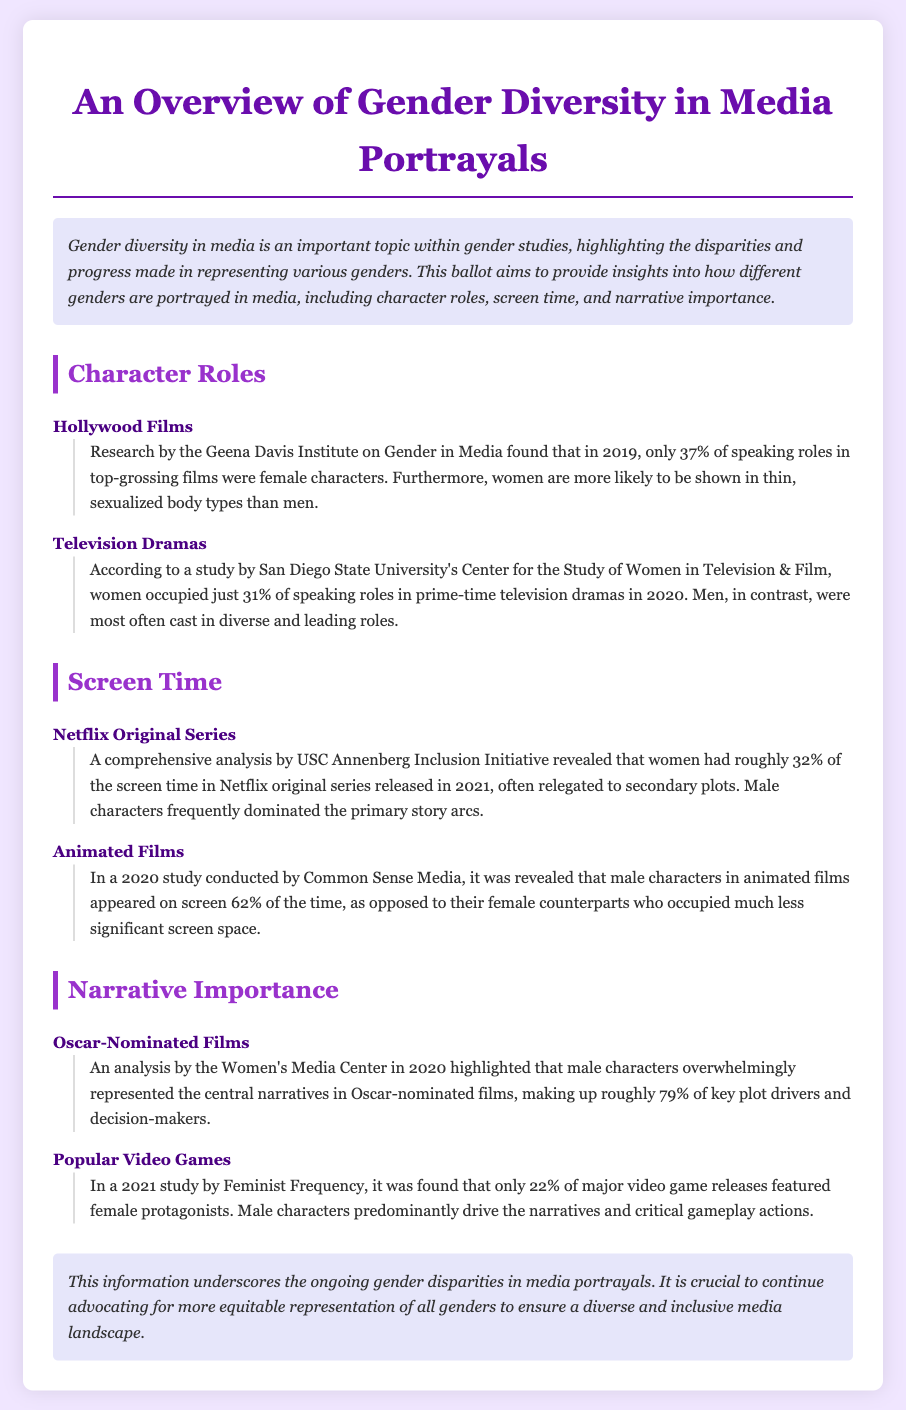What percentage of speaking roles in top-grossing films were female characters in 2019? The document states that only 37% of speaking roles in top-grossing films were female characters.
Answer: 37% What percentage of speaking roles did women occupy in prime-time television dramas in 2020? According to the study mentioned, women occupied just 31% of speaking roles in prime-time television dramas in 2020.
Answer: 31% What was the screen time percentage for women in Netflix original series released in 2021? The analysis revealed that women had roughly 32% of the screen time in Netflix original series released in 2021.
Answer: 32% What percentage of male characters appeared on screen in animated films according to the 2020 study? The study conducted by Common Sense Media revealed that male characters in animated films appeared on screen 62% of the time.
Answer: 62% What percentage of key plot drivers in Oscar-nominated films were male characters in 2020? The document notes that male characters overwhelmingly represented about 79% of key plot drivers in Oscar-nominated films.
Answer: 79% What percentage of major video game releases featured female protagonists in 2021? The study found that only 22% of major video game releases featured female protagonists.
Answer: 22% What is the overall theme of this ballot? The ballot provides insights into gender diversity in media portrayals, highlighting disparities and progress in representing various genders.
Answer: Gender diversity in media portrayals What type of media portrayals does the document focus on? The document focuses on portrayals in Hollywood films, television dramas, Netflix original series, animated films, and video games.
Answer: Hollywood films, television dramas, Netflix original series, animated films, and video games 